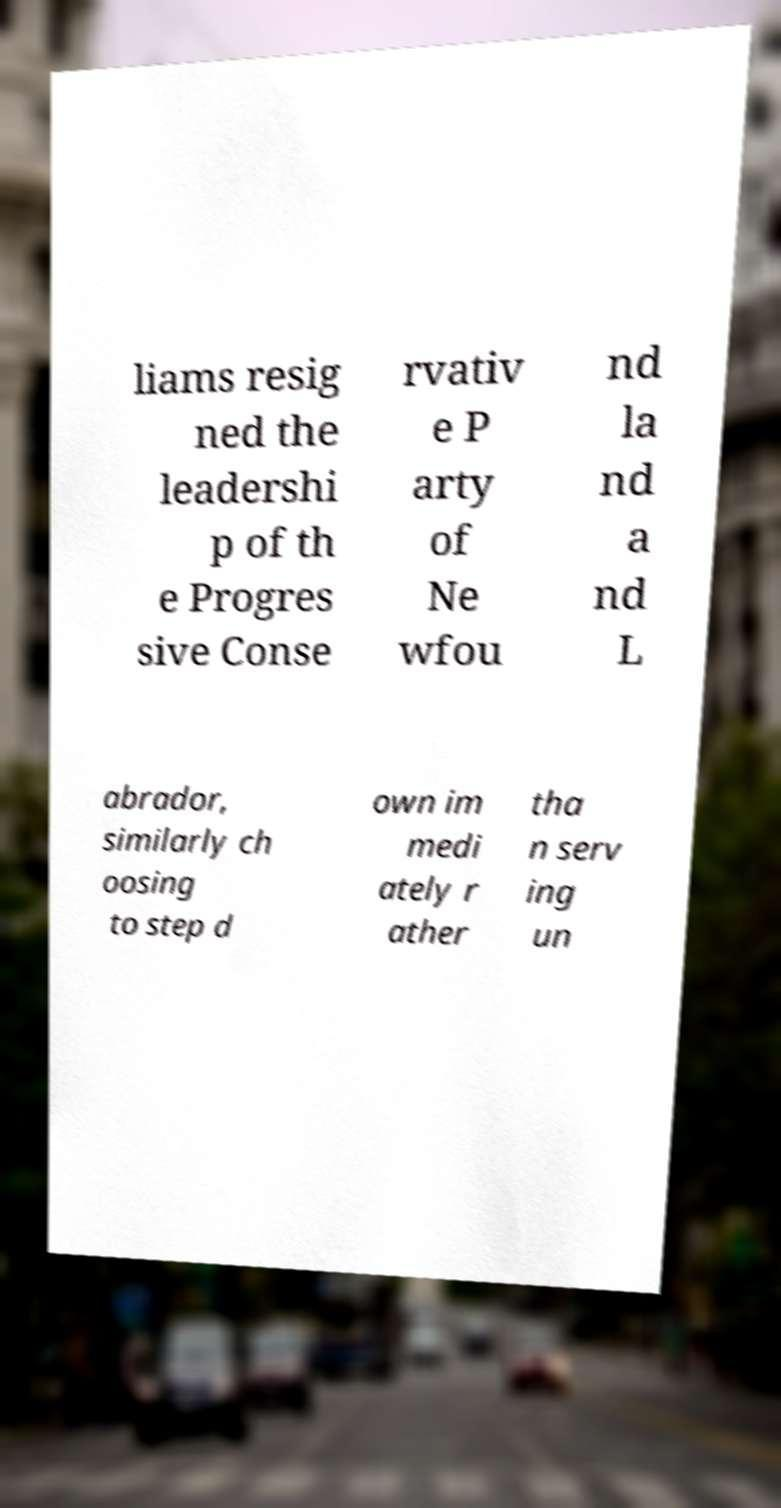What messages or text are displayed in this image? I need them in a readable, typed format. liams resig ned the leadershi p of th e Progres sive Conse rvativ e P arty of Ne wfou nd la nd a nd L abrador, similarly ch oosing to step d own im medi ately r ather tha n serv ing un 